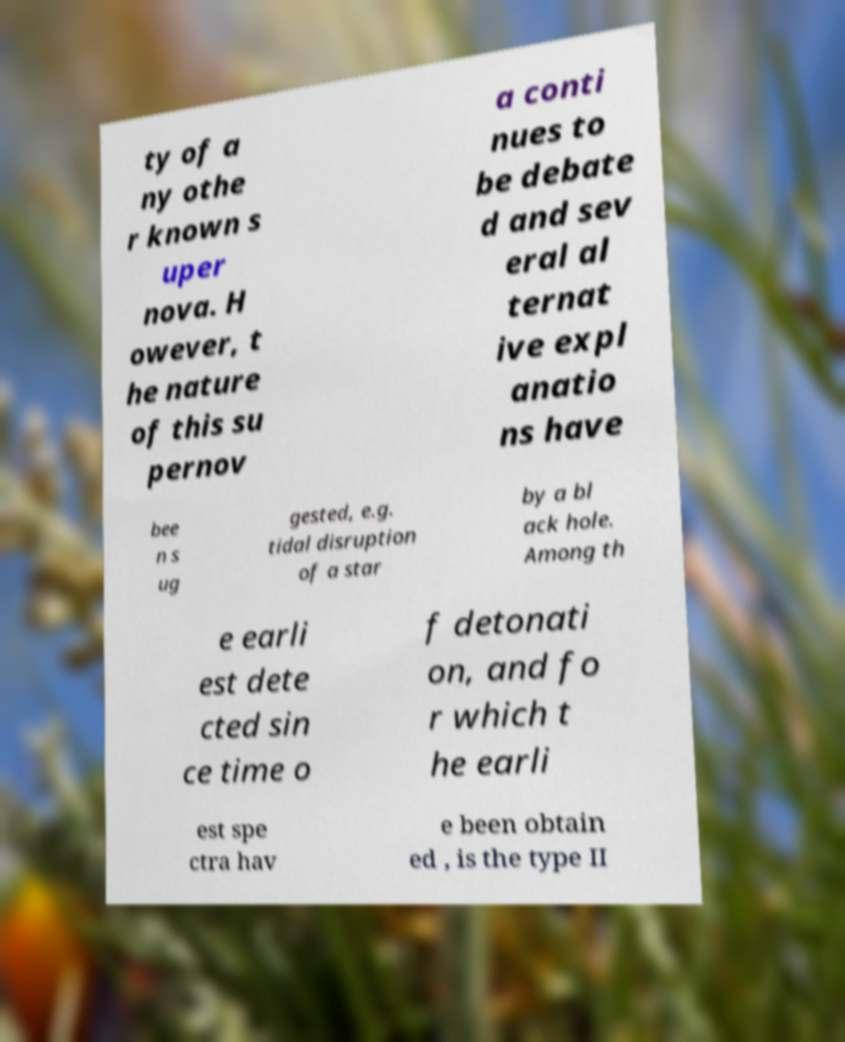Could you extract and type out the text from this image? ty of a ny othe r known s uper nova. H owever, t he nature of this su pernov a conti nues to be debate d and sev eral al ternat ive expl anatio ns have bee n s ug gested, e.g. tidal disruption of a star by a bl ack hole. Among th e earli est dete cted sin ce time o f detonati on, and fo r which t he earli est spe ctra hav e been obtain ed , is the type II 